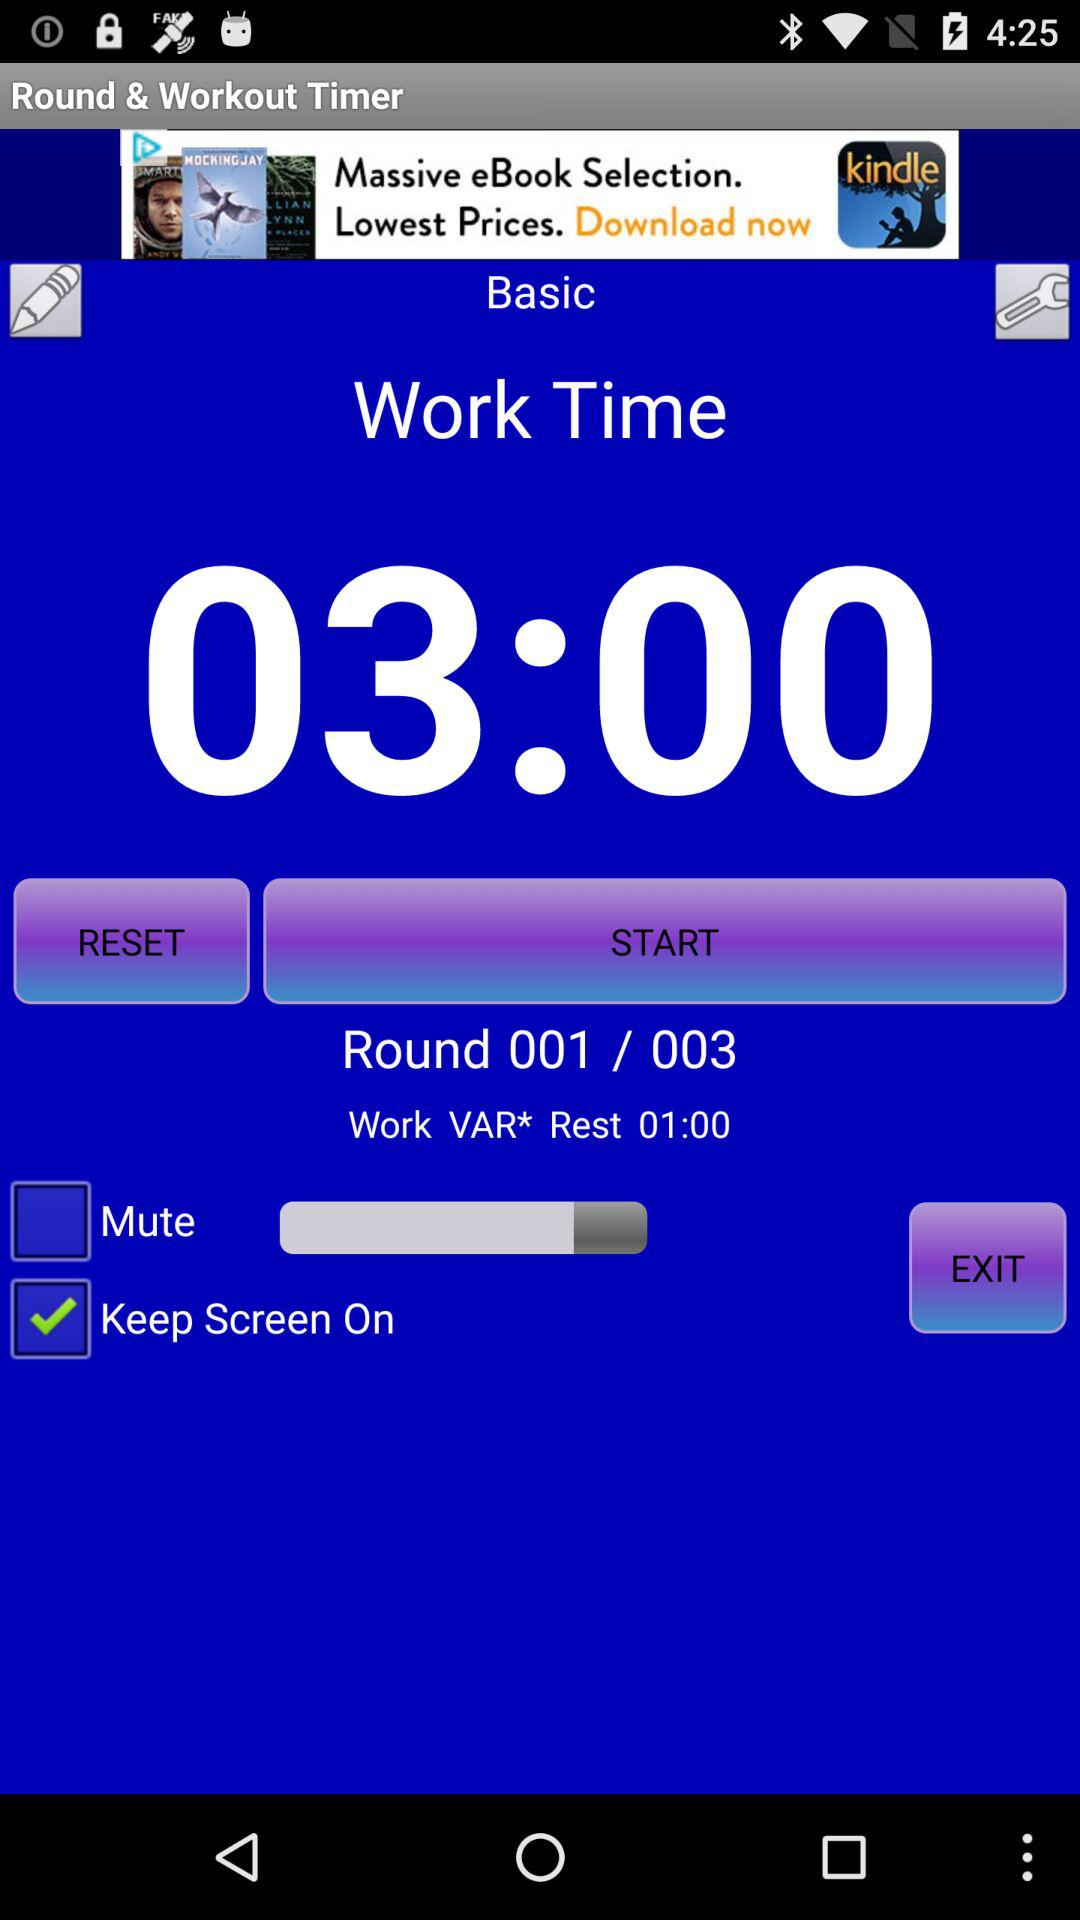How many rounds in total are there? There are 3 rounds in total. 